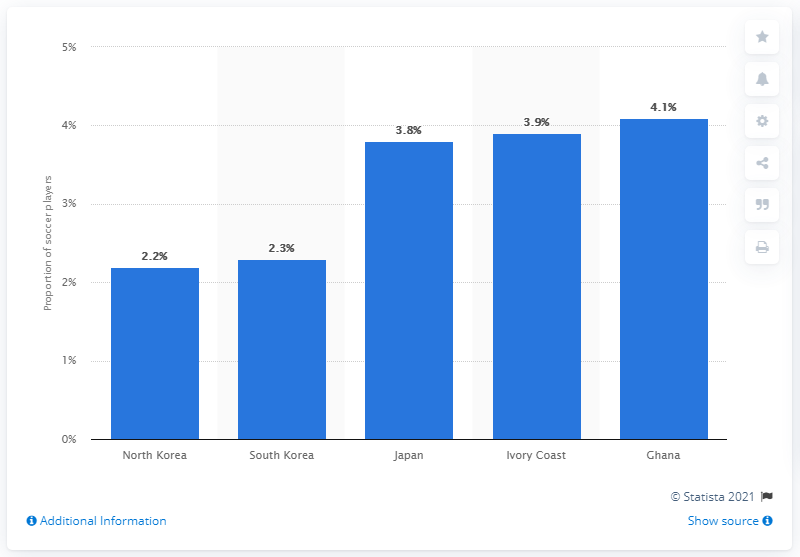Outline some significant characteristics in this image. A significant portion of Japan's population, approximately 3.8%, are professional soccer players. 